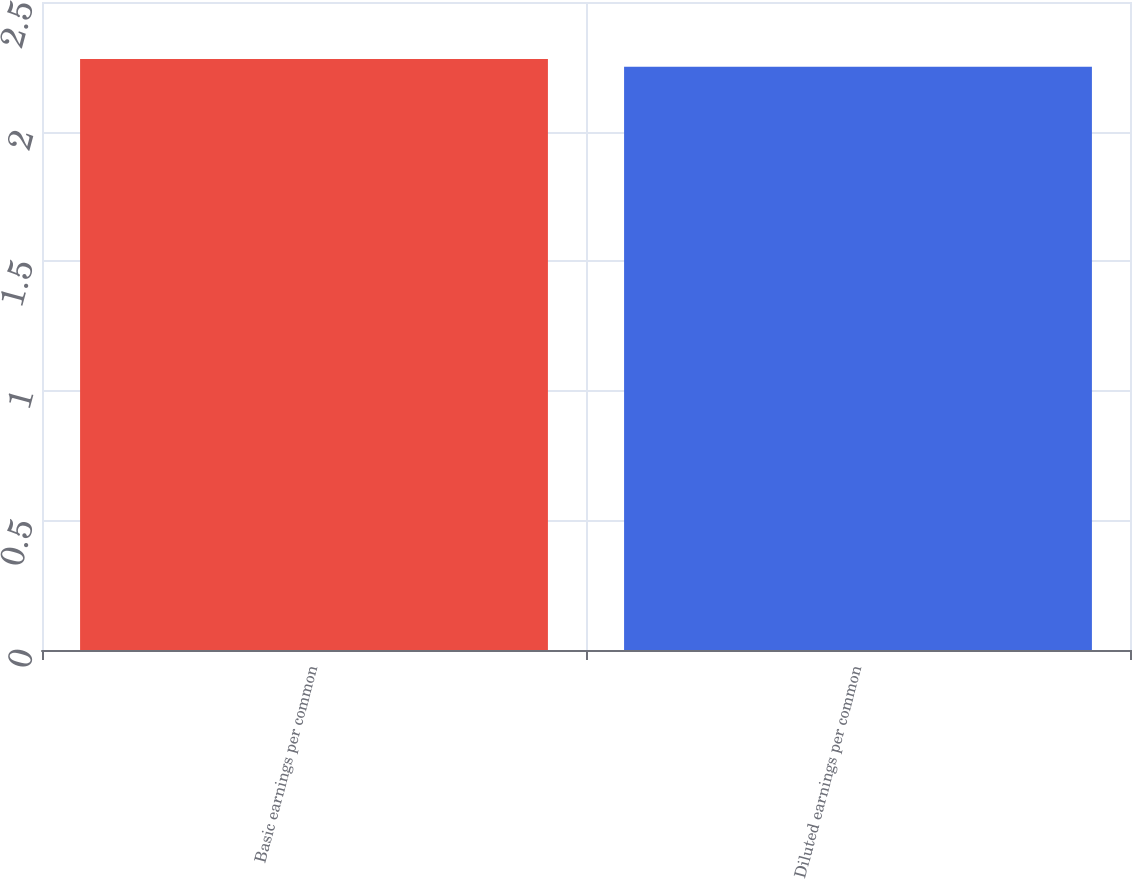<chart> <loc_0><loc_0><loc_500><loc_500><bar_chart><fcel>Basic earnings per common<fcel>Diluted earnings per common<nl><fcel>2.28<fcel>2.25<nl></chart> 